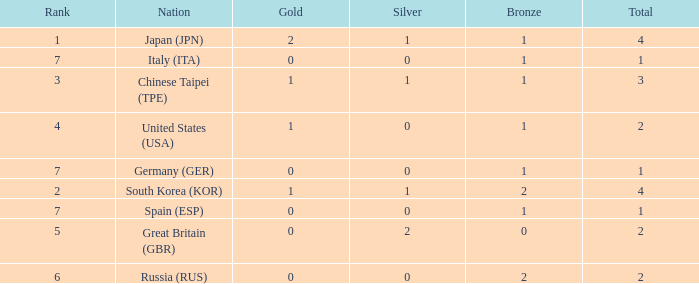What is the rank of the country with more than 2 medals, and 2 gold medals? 1.0. 